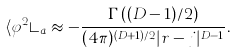<formula> <loc_0><loc_0><loc_500><loc_500>\langle \varphi ^ { 2 } \rangle _ { a } \approx - \frac { \Gamma \left ( ( D - 1 ) / 2 \right ) } { ( 4 \pi ) ^ { ( D + 1 ) / 2 } | r - j | ^ { D - 1 } } .</formula> 